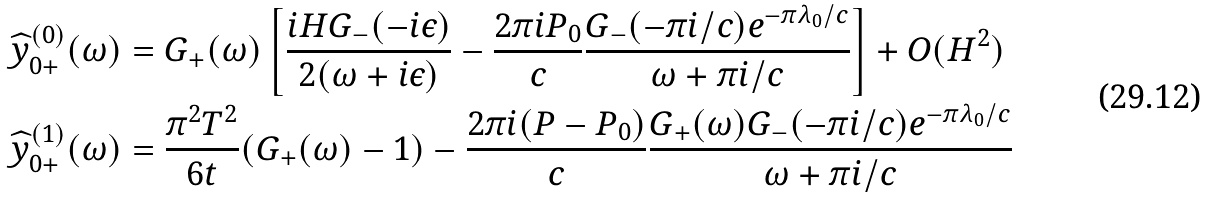<formula> <loc_0><loc_0><loc_500><loc_500>& \widehat { y } _ { 0 + } ^ { ( 0 ) } ( \omega ) = G _ { + } ( \omega ) \left [ \frac { i H G _ { - } ( - i \epsilon ) } { 2 ( \omega + i \epsilon ) } - \frac { 2 \pi i P _ { 0 } } { c } \frac { G _ { - } ( - \pi i / c ) e ^ { - \pi \lambda _ { 0 } / c } } { \omega + \pi i / c } \right ] + O ( H ^ { 2 } ) \\ & \widehat { y } _ { 0 + } ^ { ( 1 ) } ( \omega ) = \frac { \pi ^ { 2 } T ^ { 2 } } { 6 t } ( G _ { + } ( \omega ) - 1 ) - \frac { 2 \pi i ( P - P _ { 0 } ) } { c } \frac { G _ { + } ( \omega ) G _ { - } ( - \pi i / c ) e ^ { - \pi \lambda _ { 0 } / c } } { \omega + \pi i / c }</formula> 